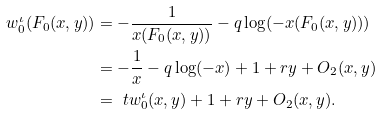Convert formula to latex. <formula><loc_0><loc_0><loc_500><loc_500>w ^ { \iota } _ { 0 } ( F _ { 0 } ( x , y ) ) & = - \frac { 1 } { x ( F _ { 0 } ( x , y ) ) } - q \log ( - x ( F _ { 0 } ( x , y ) ) ) \\ & = - \frac { 1 } { x } - q \log ( - x ) + 1 + r y + O _ { 2 } ( x , y ) \\ & = \ t w ^ { \iota } _ { 0 } ( x , y ) + 1 + r y + O _ { 2 } ( x , y ) .</formula> 